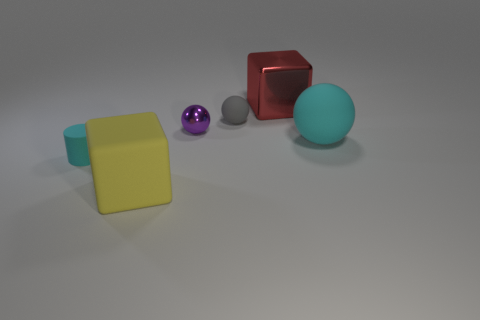Can you describe the color and shape of the objects at the front? The objects at the forefront include a yellow cube and a turquoise sphere. The cube has a solid and uniform yellow color, showcasing a typical cubic structure with equal sides. The sphere is of a smooth turquoise hue, displaying a perfect spherical shape with a matte surface. 